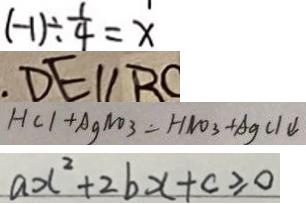<formula> <loc_0><loc_0><loc_500><loc_500>( - 1 ) \div \frac { 1 } { 4 } = x 
 D E / / B C 
 H C l + A g N O _ { 3 } = H N O _ { 3 } + A g C l \downarrow 
 a x ^ { 2 } + 2 b x + c \geq 0</formula> 